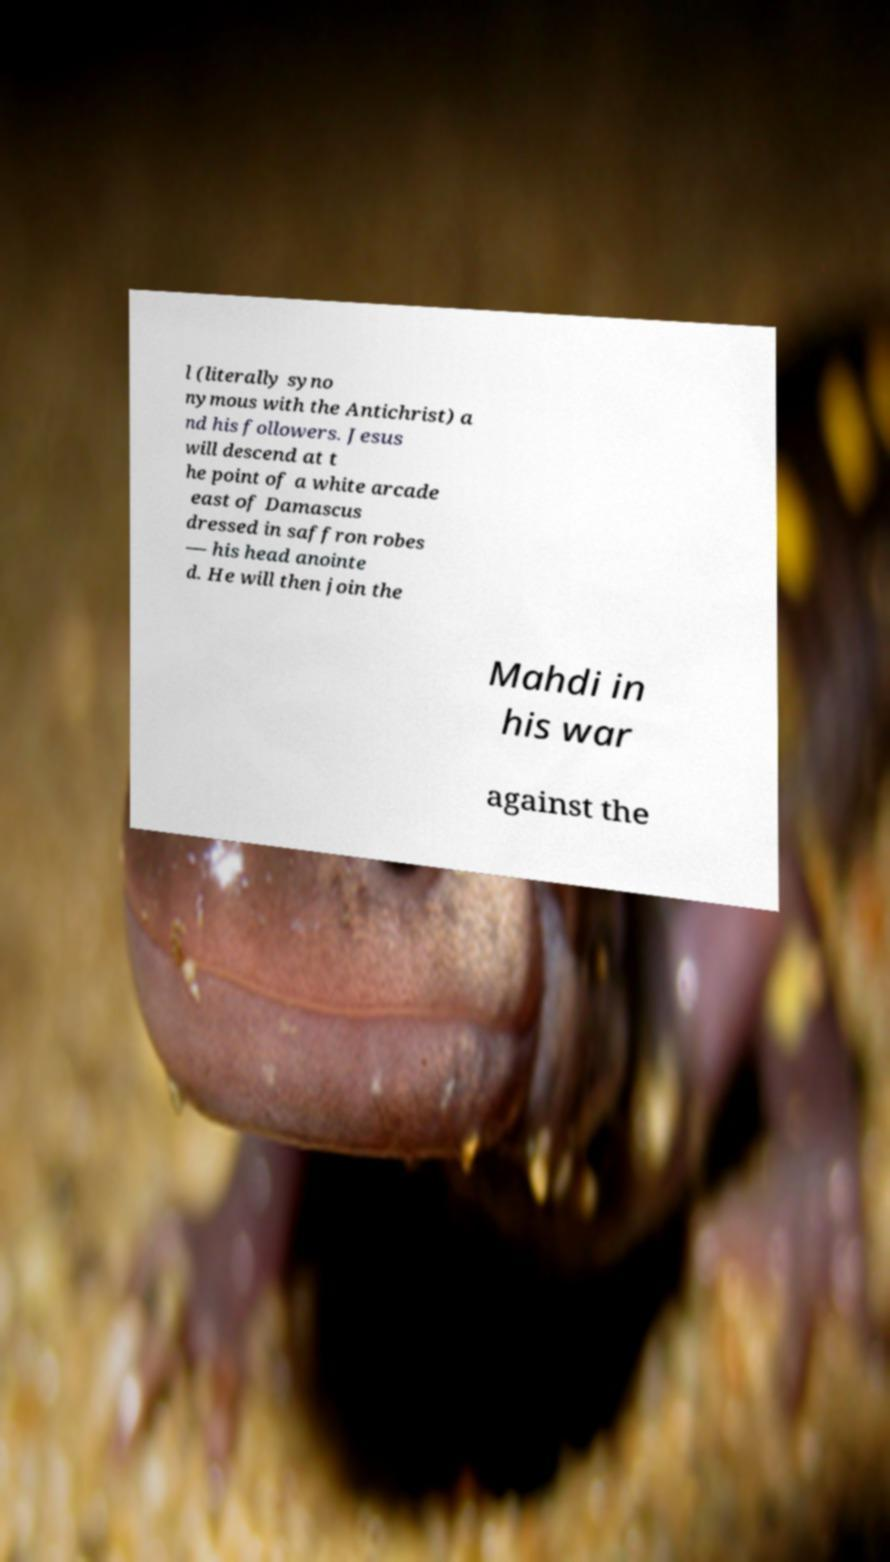There's text embedded in this image that I need extracted. Can you transcribe it verbatim? l (literally syno nymous with the Antichrist) a nd his followers. Jesus will descend at t he point of a white arcade east of Damascus dressed in saffron robes — his head anointe d. He will then join the Mahdi in his war against the 